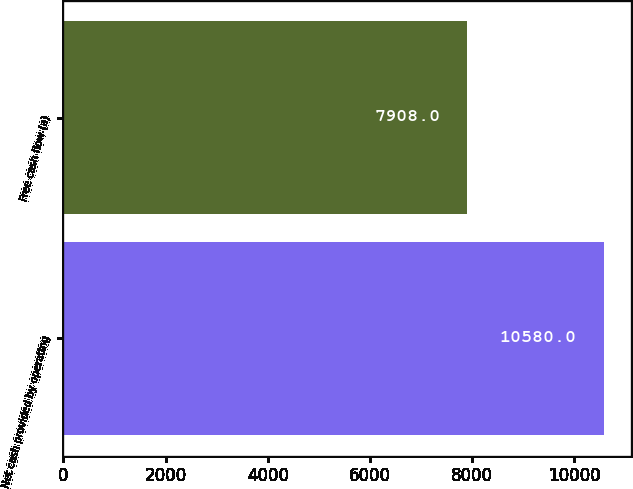Convert chart to OTSL. <chart><loc_0><loc_0><loc_500><loc_500><bar_chart><fcel>Net cash provided by operating<fcel>Free cash flow (a)<nl><fcel>10580<fcel>7908<nl></chart> 